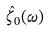Convert formula to latex. <formula><loc_0><loc_0><loc_500><loc_500>\hat { \zeta } _ { 0 } ( \omega )</formula> 